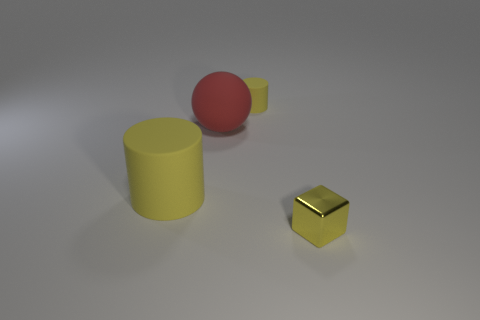Add 2 small rubber objects. How many objects exist? 6 Subtract 1 cylinders. How many cylinders are left? 1 Subtract all cubes. How many objects are left? 3 Subtract all brown balls. How many green cylinders are left? 0 Add 3 rubber cylinders. How many rubber cylinders are left? 5 Add 4 tiny red rubber cylinders. How many tiny red rubber cylinders exist? 4 Subtract 1 red balls. How many objects are left? 3 Subtract all blue blocks. Subtract all green cylinders. How many blocks are left? 1 Subtract all large yellow cylinders. Subtract all large objects. How many objects are left? 1 